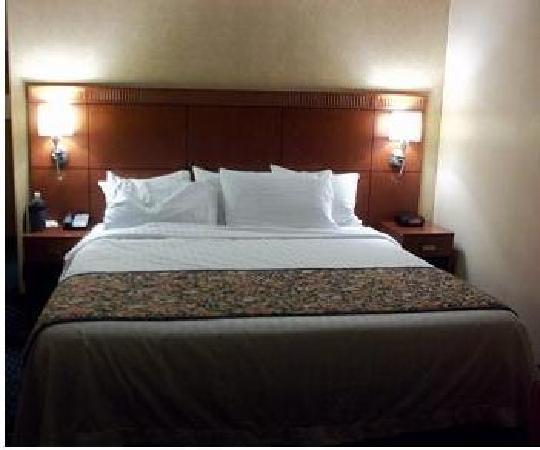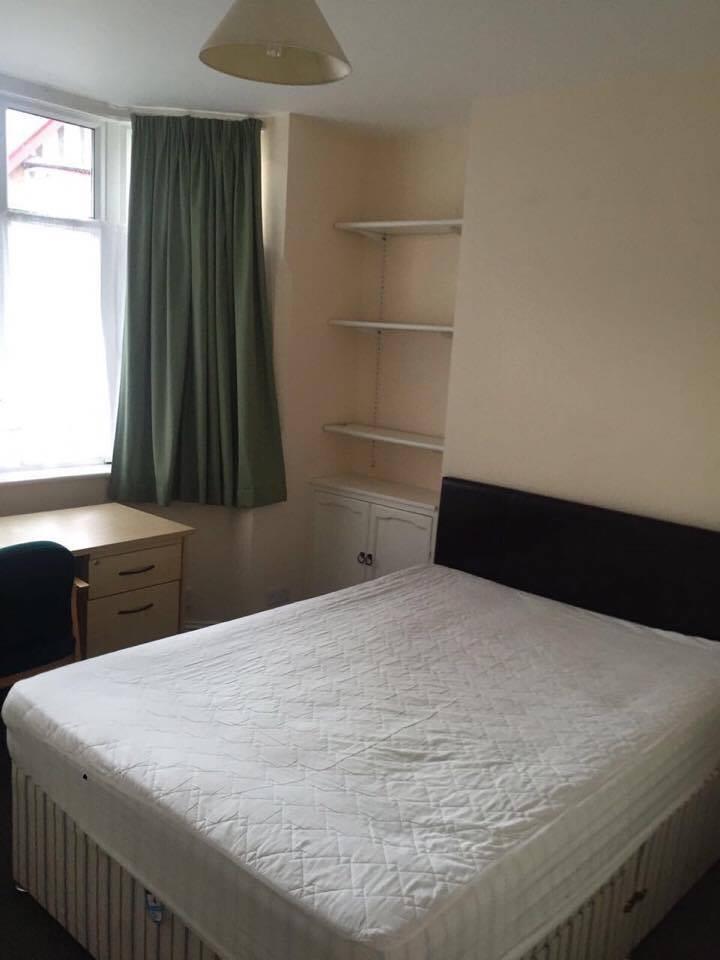The first image is the image on the left, the second image is the image on the right. Given the left and right images, does the statement "There are no less than three beds" hold true? Answer yes or no. No. The first image is the image on the left, the second image is the image on the right. For the images displayed, is the sentence "In 1 of the images, 1 bed is in front of a dimpled headboard." factually correct? Answer yes or no. No. 